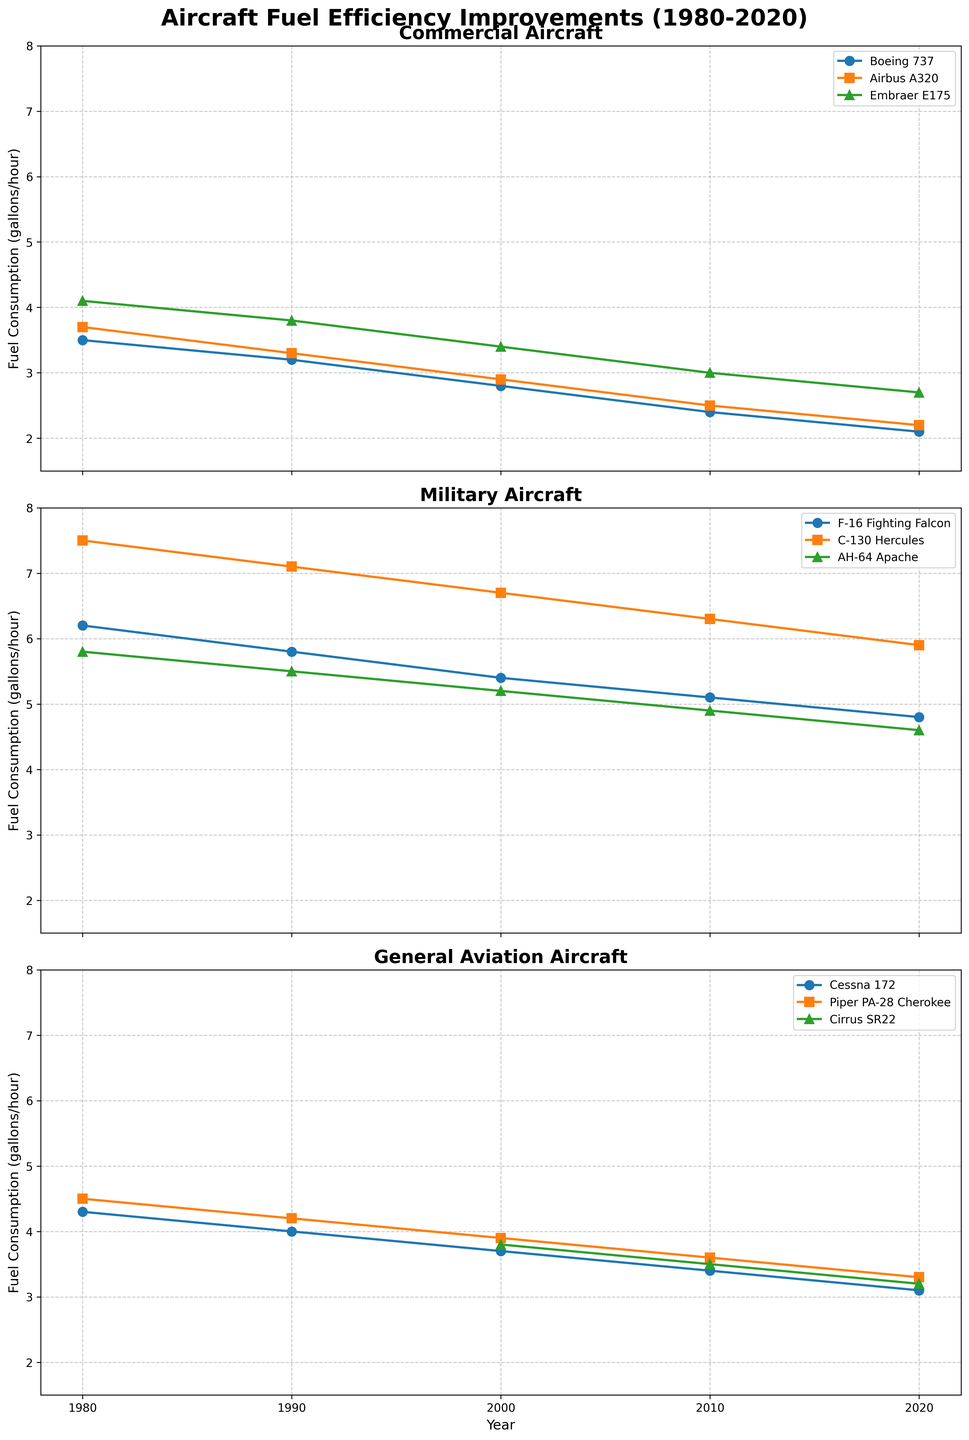what is the common title of the figure? The common title is shown at the top of the figure and reads clearly as "Aircraft Fuel Efficiency Improvements (1980-2020)", indicating the focus of the figure.
Answer: Aircraft Fuel Efficiency Improvements (1980-2020) how many subplots are there in the figure? The figure contains three distinct subplots stacked vertically under the main title.
Answer: three what are the categories represented by the subplots? The titles of the individual subplots indicate that the categories represented are "Commercial Aircraft," "Military Aircraft," and "General Aviation Aircraft," each occupying a separate subplot.
Answer: Commercial Aircraft, Military Aircraft, General Aviation Aircraft which commercial aircraft showed the most improvement in fuel efficiency from 1980 to 2020? By observing the steepest decline in the plotted lines within the Commercial Aircraft subplot, the Boeing 737 shows a decrease from 3.5 gallons per hour in 1980 to 2.1 gallons per hour in 2020, indicating the most significant improvement.
Answer: Boeing 737 what year does the x-axis represent? The x-axis of the figure includes labels that clearly denote the years 1980, 1990, 2000, 2010, and 2020.
Answer: 1980, 1990, 2000, 2010, 2020 did any general aviation aircraft’s fuel consumption remain constant over any decade? By inspecting each line in the General Aviation subplot, we see that none of the aircraft's fuel consumption lines are flat; they all show a reduction over every decade.
Answer: no among military aircraft, which had the least fuel consumption in 2020? By comparing the end points of the lines in the Military Aircraft subplot at 2020, the AH-64 Apache has the lowest fuel consumption of 4.6 gallons per hour.
Answer: AH-64 Apache which aircraft had no data for 1980 and 1990 in the General Aviation category? The Cirrus SR22 is represented by a line that only starts from 2000 onwards in the General Aviation subplot, indicating no data for 1980 and 1990.
Answer: Cirrus SR22 between 2010 to 2020, which commercial aircraft showed the largest decrease in fuel consumption? Comparing the slopes of the lines in the Commercial Aircraft subplot from 2010 to 2020, the Embraer E175 shows the largest decrease, going from 3.0 to 2.7 gallons per hour.
Answer: Embraer E175 which aircraft had the highest fuel consumption in the military category in 1990? By observing the plots in the Military Aircraft subplot, the C-130 Hercules had the highest fuel consumption at 7.1 gallons per hour in 1990.
Answer: C-130 Hercules 